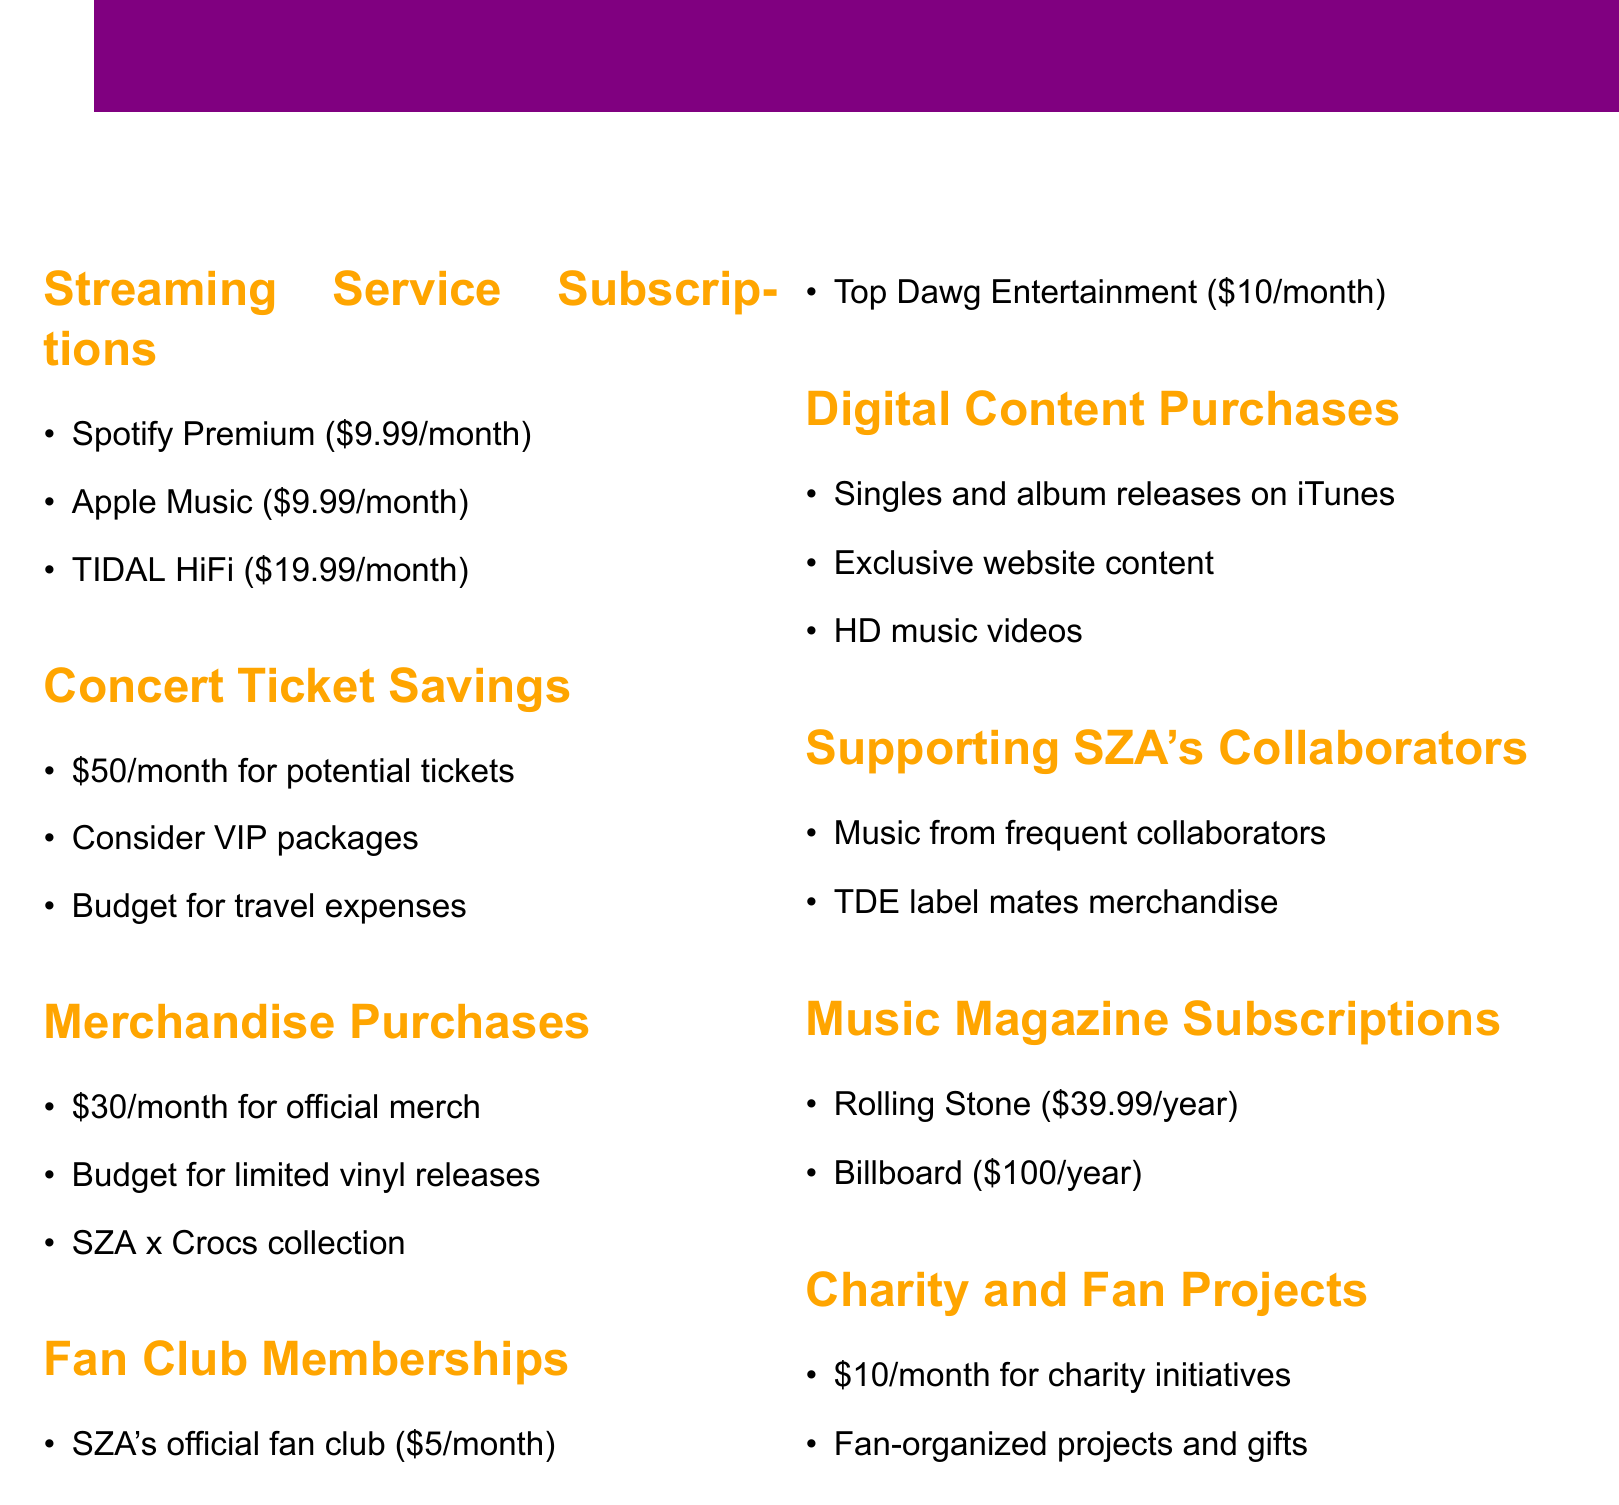What is the monthly cost for Spotify Premium? The monthly cost for Spotify Premium is mentioned in the document as $9.99/month.
Answer: $9.99/month How much is allocated for potential concert tickets each month? The document states that $50/month is set aside for potential SZA concert tickets.
Answer: $50/month What is the budget for official merchandise purchases? The budget for official SZA merchandise from her website is listed as $30/month.
Answer: $30/month What year is the Rolling Stone subscription fee calculated for? The Rolling Stone subscription fee is presented in the document as a yearly amount, specifically $39.99/year.
Answer: year How much is the total monthly budget for Fan Club Memberships? The total monthly budget for fan club memberships includes $5 for SZA's official fan club and $10 for Top Dawg Entertainment, leading to a total of $15.
Answer: $15 Which artist's merchandise is suggested for allocation besides SZA? The document notes that funds should be allocated for purchasing merchandise from TDE label mates like Kendrick Lamar and Isaiah Rashad.
Answer: Kendrick Lamar What is the monthly budget for charity initiatives related to SZA? The monthly budget for charity initiatives related to SZA is stated as $10/month in the document.
Answer: $10/month How much is set aside for digital content purchases on iTunes? The document does not specify an exact dollar amount set aside for digital content purchases on iTunes, but indicates that a budget should be allocated.
Answer: Not specified What type of exclusive content can be purchased directly on SZA's website? The document mentions that exclusive digital content can be purchased on SZA's website.
Answer: Exclusive digital content 